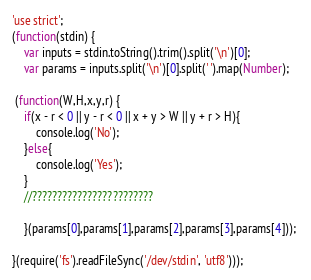<code> <loc_0><loc_0><loc_500><loc_500><_JavaScript_>'use strict';
(function(stdin) {
    var inputs = stdin.toString().trim().split('\n')[0];
    var params = inputs.split('\n')[0].split(' ').map(Number);

 (function(W,H,x,y,r) {
    if(x - r < 0 || y - r < 0 || x + y > W || y + r > H){
        console.log('No');
    }else{
        console.log('Yes');
    }
    //????????????????????????

    }(params[0],params[1],params[2],params[3],params[4])); 

}(require('fs').readFileSync('/dev/stdin', 'utf8')));</code> 